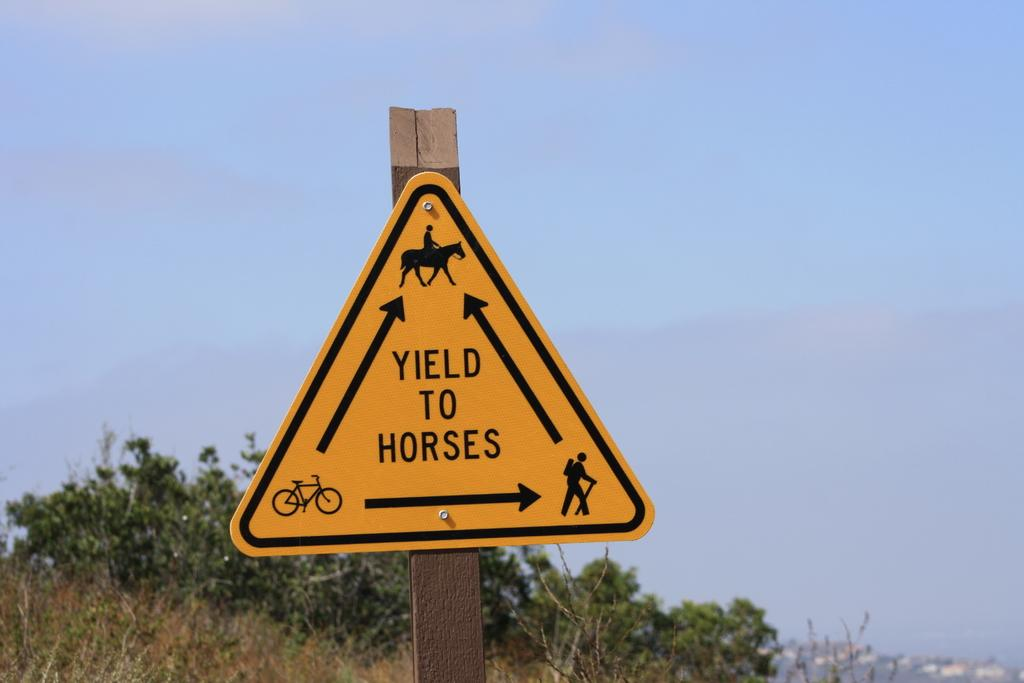Provide a one-sentence caption for the provided image. A triangle sign that tells you to yield to horses while showing hiker, bike and horse. 